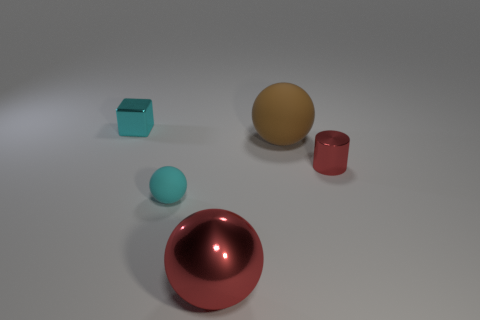Add 4 small cyan blocks. How many objects exist? 9 Subtract all blocks. How many objects are left? 4 Add 3 cyan matte spheres. How many cyan matte spheres exist? 4 Subtract 0 blue cylinders. How many objects are left? 5 Subtract all shiny cylinders. Subtract all small matte balls. How many objects are left? 3 Add 1 big spheres. How many big spheres are left? 3 